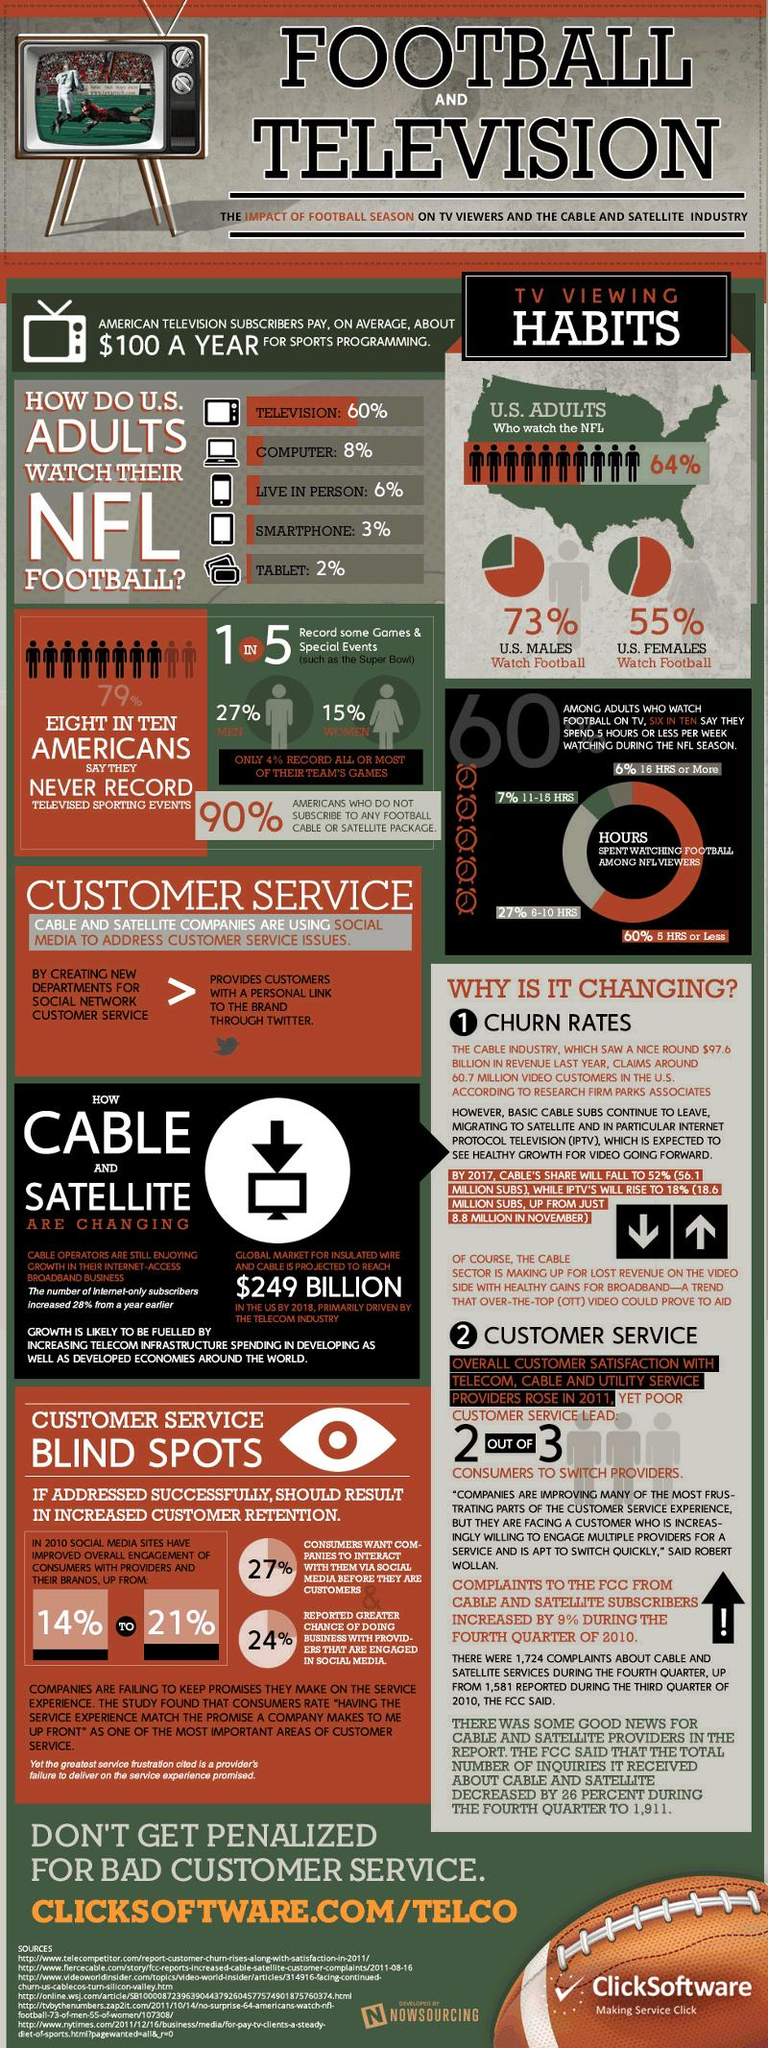Indicate a few pertinent items in this graphic. According to a recent survey, 45% of U.S. females do not watch football. The use of social media sites in 2010 has significantly improved the overall engagement of consumers with providers and brands, with an increase of 7% compared to the previous years. Four out of five people do not record some games and special events. In the United States, males are more likely to watch football than females. Approximately 36% of adults in the United States do not watch the National Football League (NFL). 